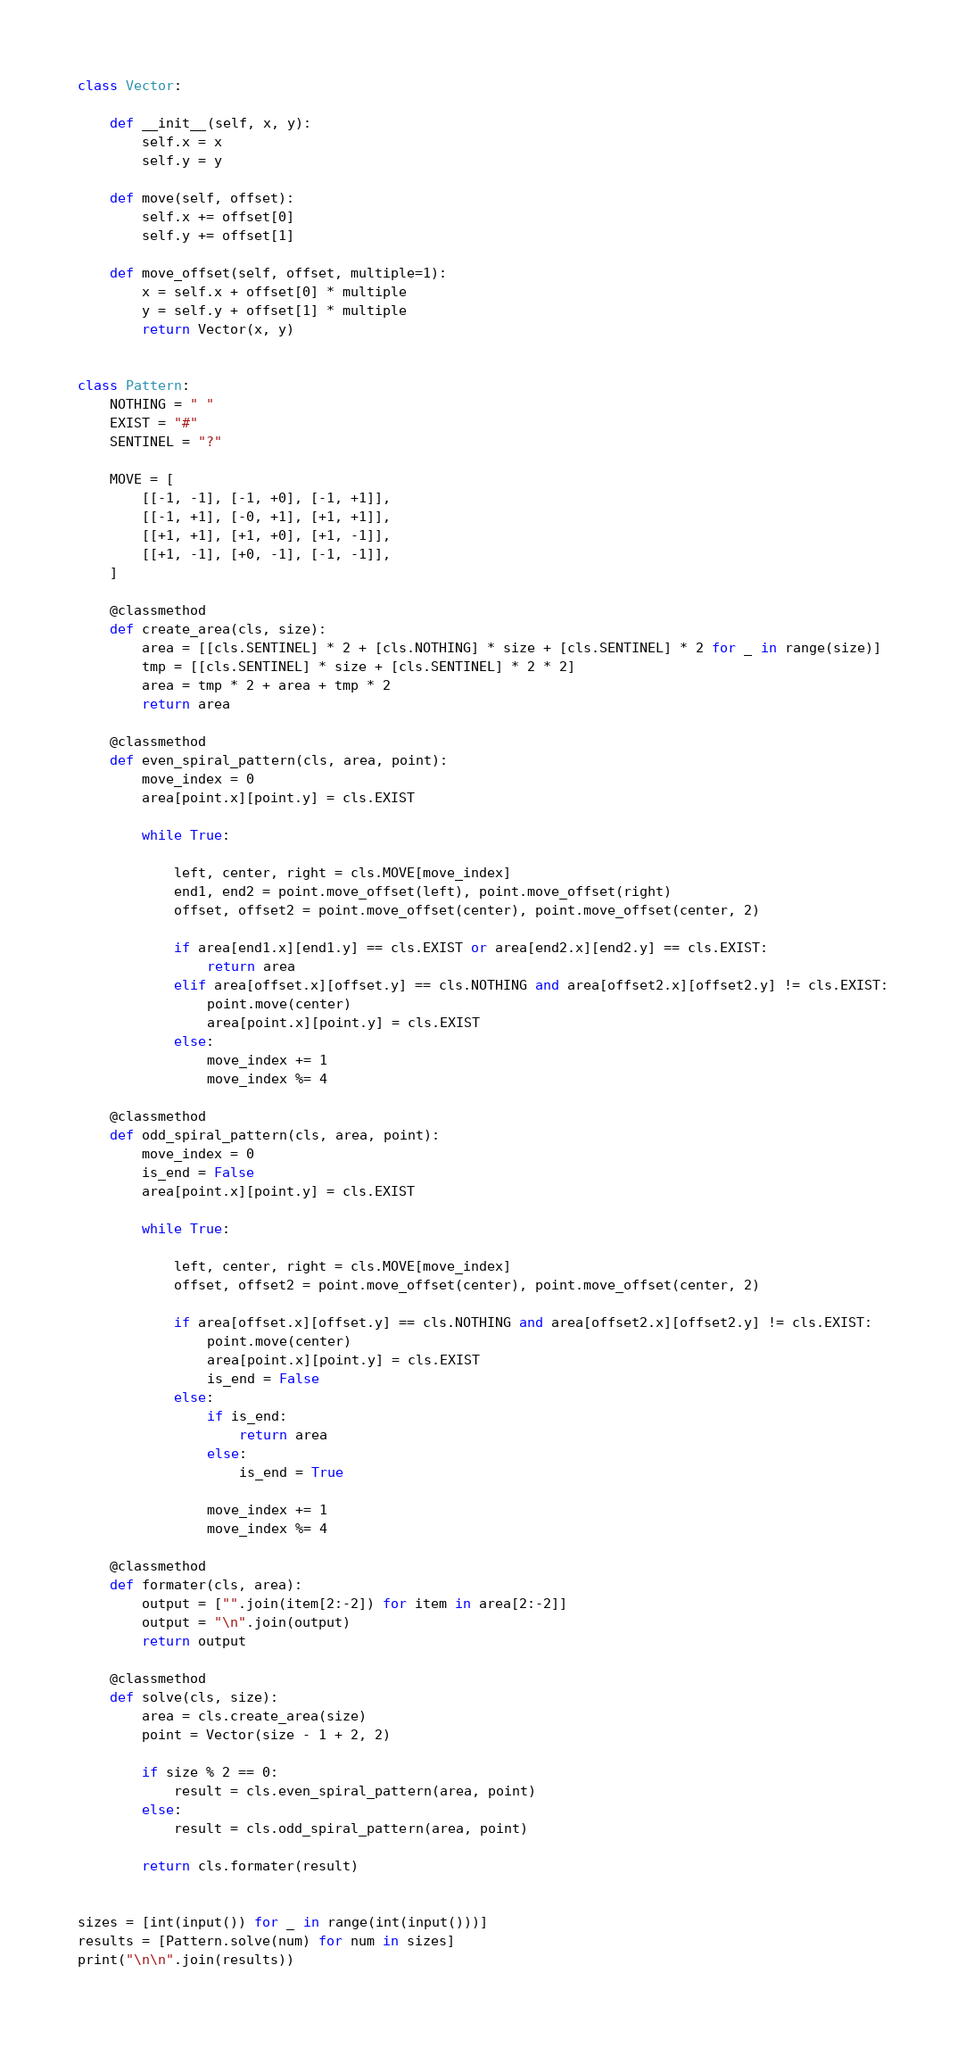Convert code to text. <code><loc_0><loc_0><loc_500><loc_500><_Python_>class Vector:

    def __init__(self, x, y):
        self.x = x
        self.y = y

    def move(self, offset):
        self.x += offset[0]
        self.y += offset[1]

    def move_offset(self, offset, multiple=1):
        x = self.x + offset[0] * multiple
        y = self.y + offset[1] * multiple
        return Vector(x, y)


class Pattern:
    NOTHING = " "
    EXIST = "#"
    SENTINEL = "?"

    MOVE = [
        [[-1, -1], [-1, +0], [-1, +1]],
        [[-1, +1], [-0, +1], [+1, +1]],
        [[+1, +1], [+1, +0], [+1, -1]],
        [[+1, -1], [+0, -1], [-1, -1]],
    ]

    @classmethod
    def create_area(cls, size):
        area = [[cls.SENTINEL] * 2 + [cls.NOTHING] * size + [cls.SENTINEL] * 2 for _ in range(size)]
        tmp = [[cls.SENTINEL] * size + [cls.SENTINEL] * 2 * 2]
        area = tmp * 2 + area + tmp * 2
        return area

    @classmethod
    def even_spiral_pattern(cls, area, point):
        move_index = 0
        area[point.x][point.y] = cls.EXIST

        while True:

            left, center, right = cls.MOVE[move_index]
            end1, end2 = point.move_offset(left), point.move_offset(right)
            offset, offset2 = point.move_offset(center), point.move_offset(center, 2)

            if area[end1.x][end1.y] == cls.EXIST or area[end2.x][end2.y] == cls.EXIST:
                return area
            elif area[offset.x][offset.y] == cls.NOTHING and area[offset2.x][offset2.y] != cls.EXIST:
                point.move(center)
                area[point.x][point.y] = cls.EXIST
            else:
                move_index += 1
                move_index %= 4

    @classmethod
    def odd_spiral_pattern(cls, area, point):
        move_index = 0
        is_end = False
        area[point.x][point.y] = cls.EXIST

        while True:

            left, center, right = cls.MOVE[move_index]
            offset, offset2 = point.move_offset(center), point.move_offset(center, 2)

            if area[offset.x][offset.y] == cls.NOTHING and area[offset2.x][offset2.y] != cls.EXIST:
                point.move(center)
                area[point.x][point.y] = cls.EXIST
                is_end = False
            else:
                if is_end:
                    return area
                else:
                    is_end = True

                move_index += 1
                move_index %= 4

    @classmethod
    def formater(cls, area):
        output = ["".join(item[2:-2]) for item in area[2:-2]]
        output = "\n".join(output)
        return output

    @classmethod
    def solve(cls, size):
        area = cls.create_area(size)
        point = Vector(size - 1 + 2, 2)

        if size % 2 == 0:
            result = cls.even_spiral_pattern(area, point)
        else:
            result = cls.odd_spiral_pattern(area, point)

        return cls.formater(result)


sizes = [int(input()) for _ in range(int(input()))]
results = [Pattern.solve(num) for num in sizes]
print("\n\n".join(results))

</code> 